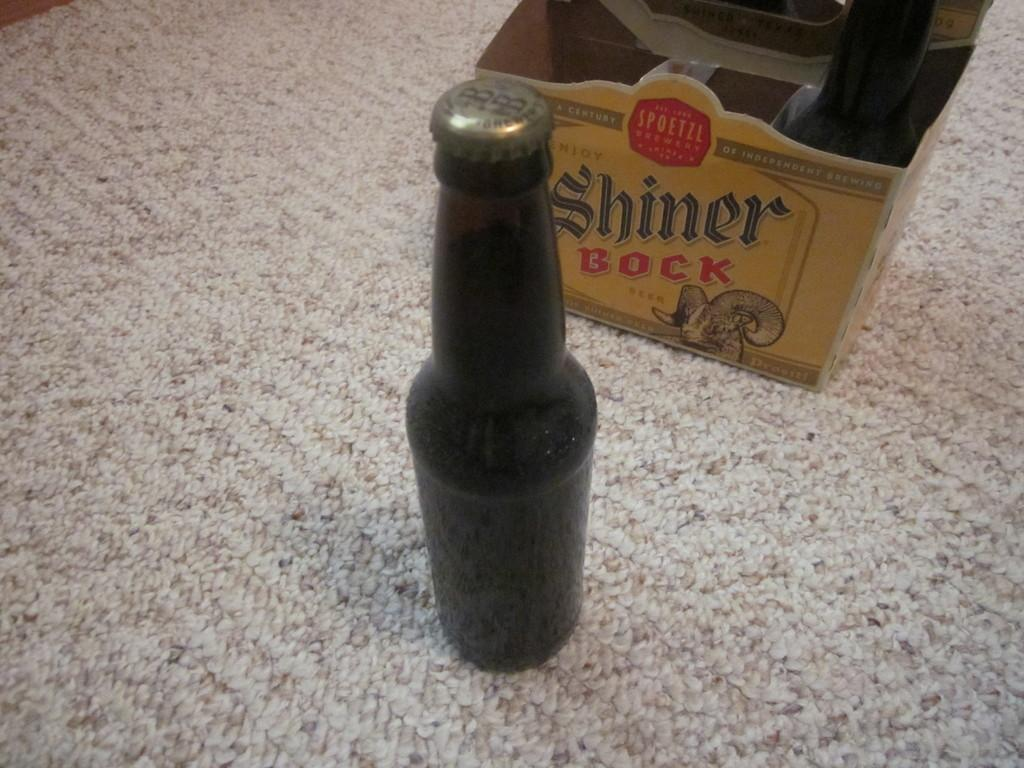<image>
Give a short and clear explanation of the subsequent image. A bottle of beer stands in front of a beer box that says Shiner Bock. 